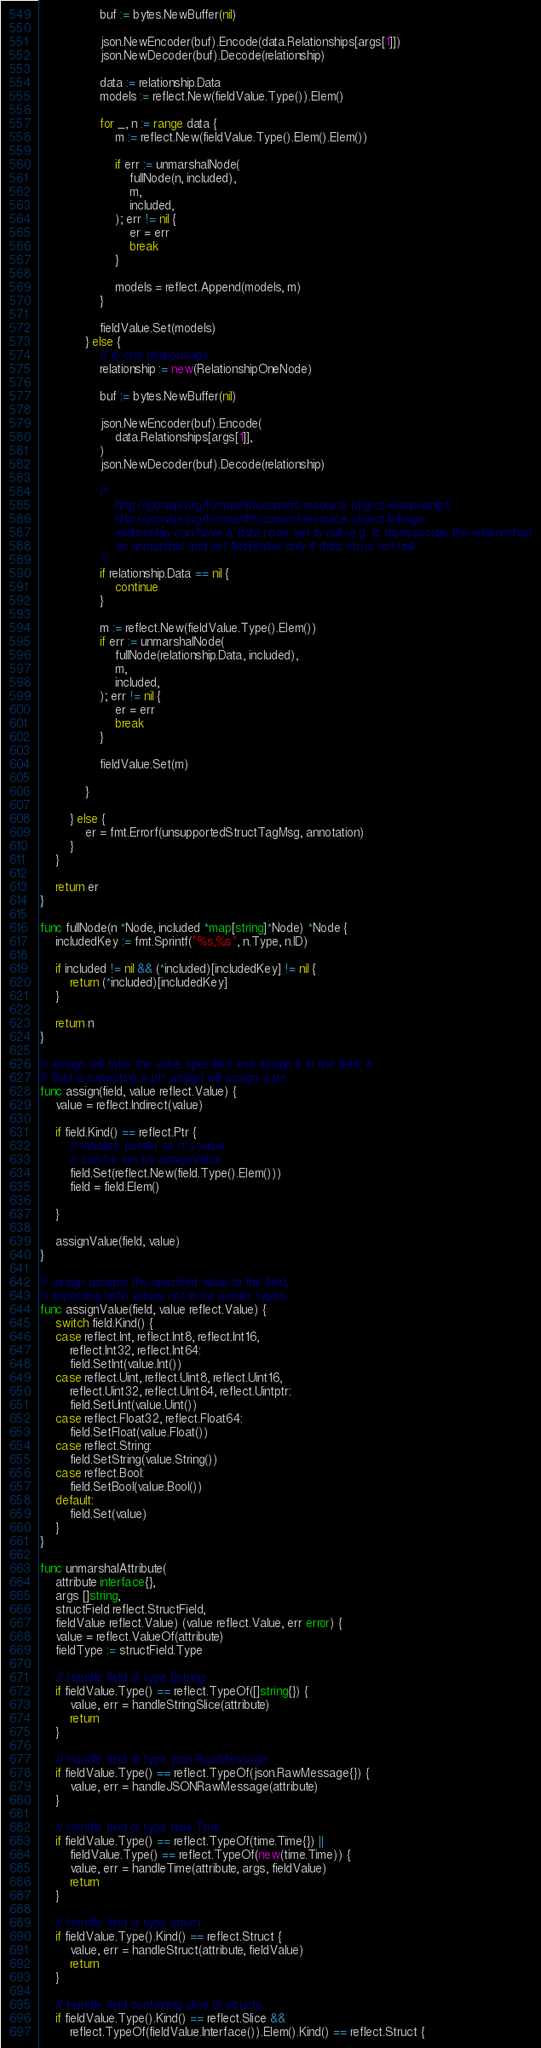Convert code to text. <code><loc_0><loc_0><loc_500><loc_500><_Go_>				buf := bytes.NewBuffer(nil)

				json.NewEncoder(buf).Encode(data.Relationships[args[1]])
				json.NewDecoder(buf).Decode(relationship)

				data := relationship.Data
				models := reflect.New(fieldValue.Type()).Elem()

				for _, n := range data {
					m := reflect.New(fieldValue.Type().Elem().Elem())

					if err := unmarshalNode(
						fullNode(n, included),
						m,
						included,
					); err != nil {
						er = err
						break
					}

					models = reflect.Append(models, m)
				}

				fieldValue.Set(models)
			} else {
				// to-one relationships
				relationship := new(RelationshipOneNode)

				buf := bytes.NewBuffer(nil)

				json.NewEncoder(buf).Encode(
					data.Relationships[args[1]],
				)
				json.NewDecoder(buf).Decode(relationship)

				/*
					http://jsonapi.org/format/#document-resource-object-relationships
					http://jsonapi.org/format/#document-resource-object-linkage
					relationship can have a data node set to null (e.g. to disassociate the relationship)
					so unmarshal and set fieldValue only if data obj is not null
				*/
				if relationship.Data == nil {
					continue
				}

				m := reflect.New(fieldValue.Type().Elem())
				if err := unmarshalNode(
					fullNode(relationship.Data, included),
					m,
					included,
				); err != nil {
					er = err
					break
				}

				fieldValue.Set(m)

			}

		} else {
			er = fmt.Errorf(unsupportedStructTagMsg, annotation)
		}
	}

	return er
}

func fullNode(n *Node, included *map[string]*Node) *Node {
	includedKey := fmt.Sprintf("%s,%s", n.Type, n.ID)

	if included != nil && (*included)[includedKey] != nil {
		return (*included)[includedKey]
	}

	return n
}

// assign will take the value specified and assign it to the field; if
// field is expecting a ptr assign will assign a ptr.
func assign(field, value reflect.Value) {
	value = reflect.Indirect(value)

	if field.Kind() == reflect.Ptr {
		// initialize pointer so it's value
		// can be set by assignValue
		field.Set(reflect.New(field.Type().Elem()))
		field = field.Elem()

	}

	assignValue(field, value)
}

// assign assigns the specified value to the field,
// expecting both values not to be pointer types.
func assignValue(field, value reflect.Value) {
	switch field.Kind() {
	case reflect.Int, reflect.Int8, reflect.Int16,
		reflect.Int32, reflect.Int64:
		field.SetInt(value.Int())
	case reflect.Uint, reflect.Uint8, reflect.Uint16,
		reflect.Uint32, reflect.Uint64, reflect.Uintptr:
		field.SetUint(value.Uint())
	case reflect.Float32, reflect.Float64:
		field.SetFloat(value.Float())
	case reflect.String:
		field.SetString(value.String())
	case reflect.Bool:
		field.SetBool(value.Bool())
	default:
		field.Set(value)
	}
}

func unmarshalAttribute(
	attribute interface{},
	args []string,
	structField reflect.StructField,
	fieldValue reflect.Value) (value reflect.Value, err error) {
	value = reflect.ValueOf(attribute)
	fieldType := structField.Type

	// Handle field of type []string
	if fieldValue.Type() == reflect.TypeOf([]string{}) {
		value, err = handleStringSlice(attribute)
		return
	}

	// Handle field of type json.RawMessage
	if fieldValue.Type() == reflect.TypeOf(json.RawMessage{}) {
		value, err = handleJSONRawMessage(attribute)
	}

	// Handle field of type time.Time
	if fieldValue.Type() == reflect.TypeOf(time.Time{}) ||
		fieldValue.Type() == reflect.TypeOf(new(time.Time)) {
		value, err = handleTime(attribute, args, fieldValue)
		return
	}

	// Handle field of type struct
	if fieldValue.Type().Kind() == reflect.Struct {
		value, err = handleStruct(attribute, fieldValue)
		return
	}

	// Handle field containing slice of structs
	if fieldValue.Type().Kind() == reflect.Slice &&
		reflect.TypeOf(fieldValue.Interface()).Elem().Kind() == reflect.Struct {</code> 